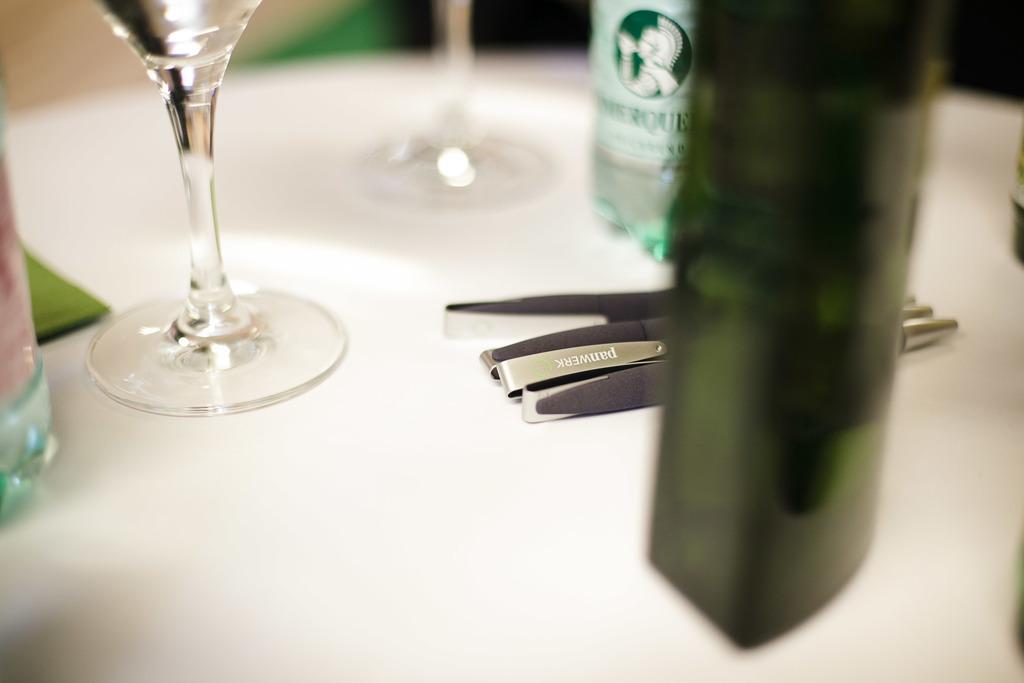Could you give a brief overview of what you see in this image? In this image we can see a glass, bottles and few pens placed on the top of the table. 